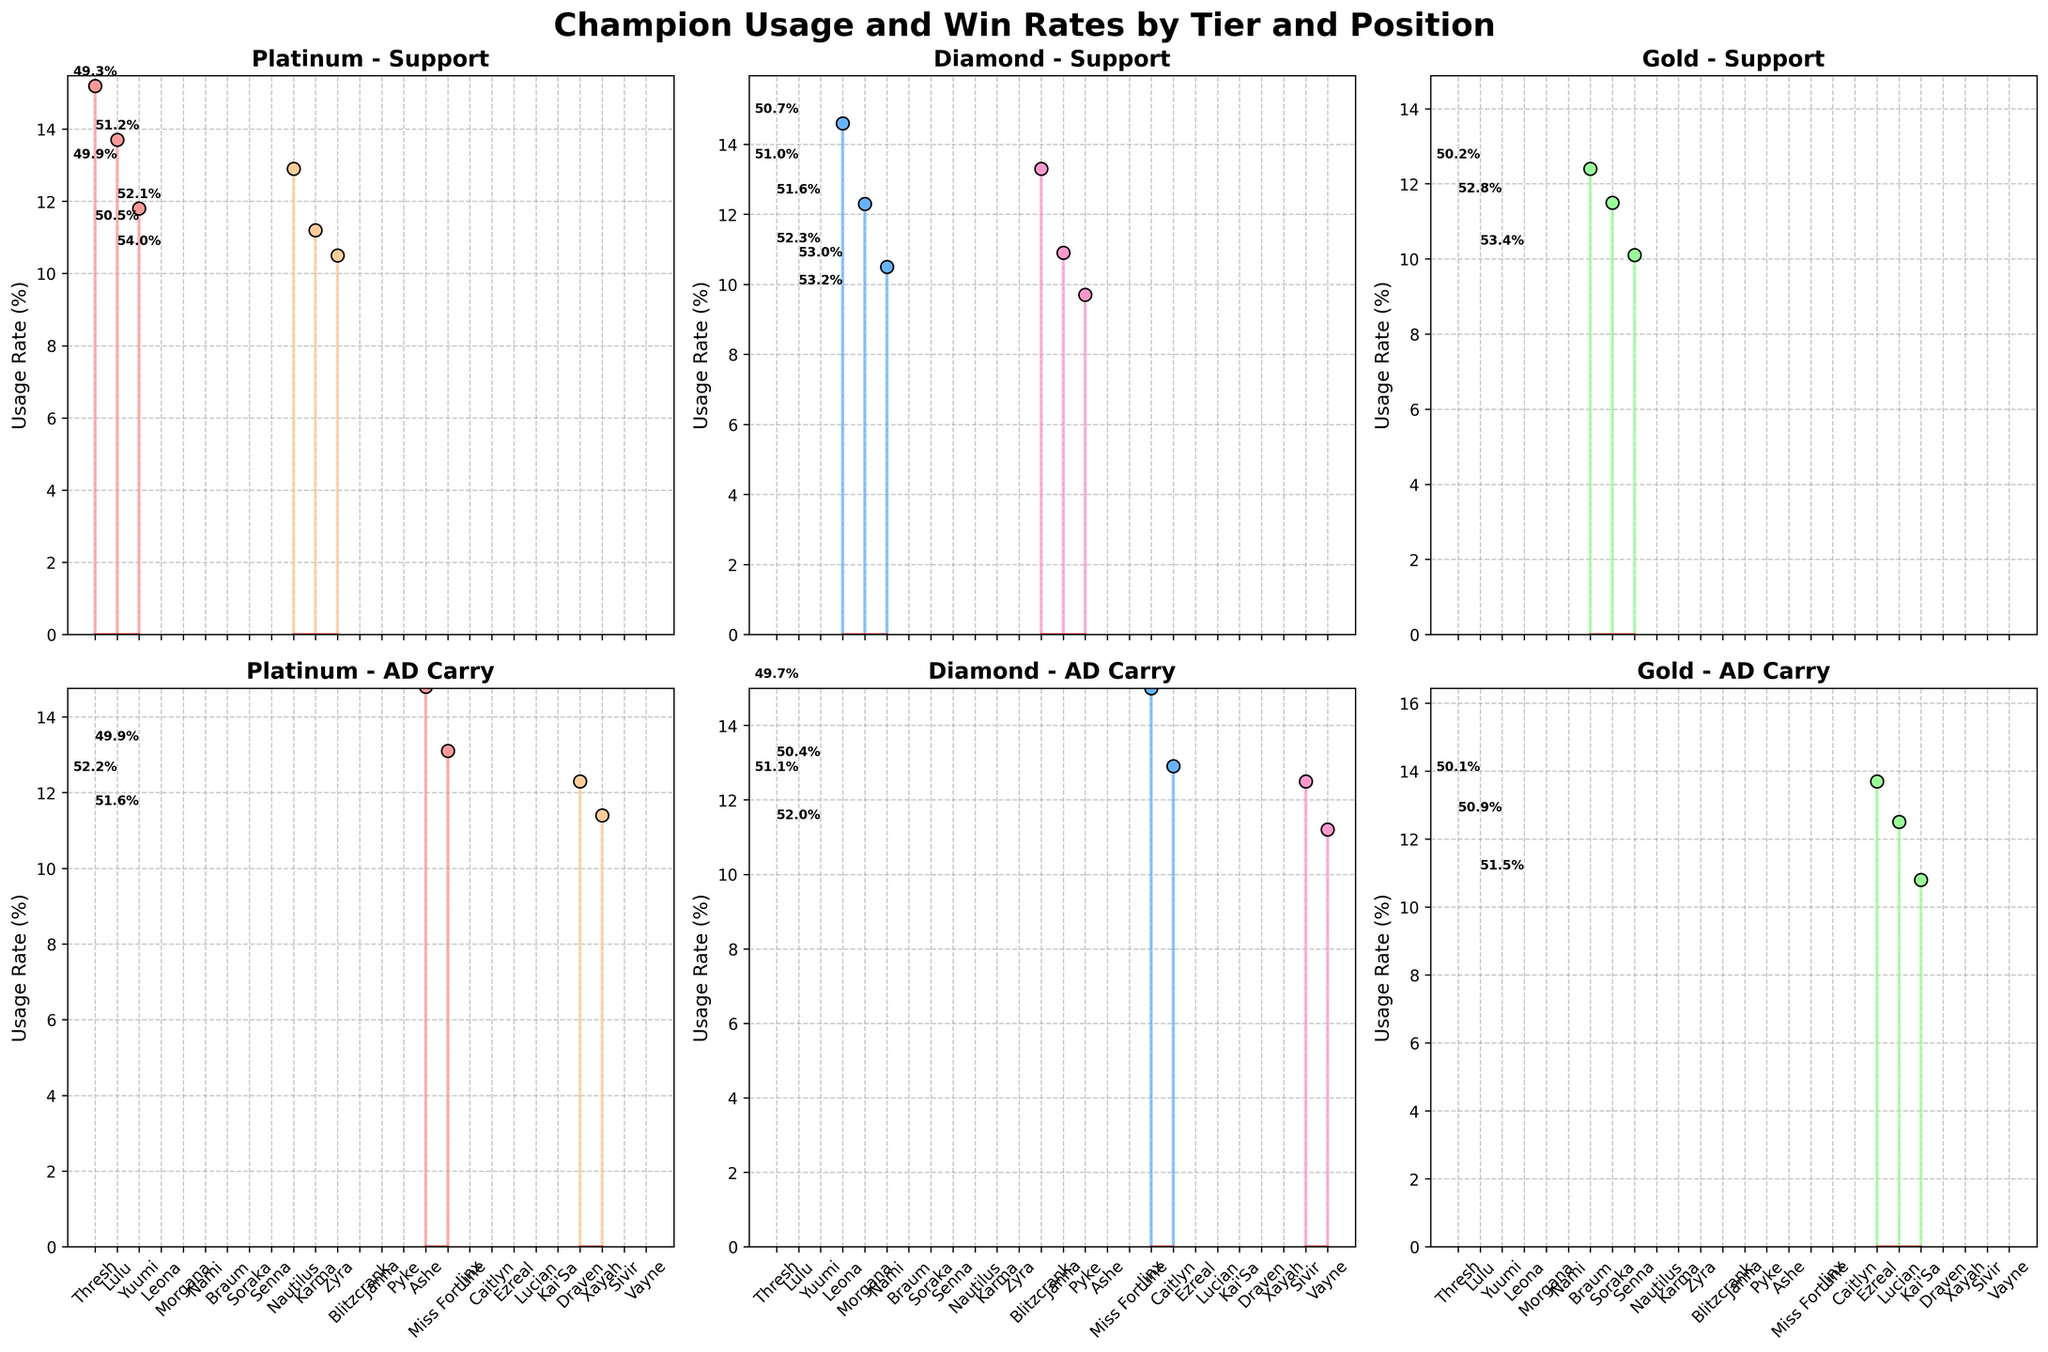What is the usage rate of Thresh in the Bronze tier as a Support? Look at the Bronze - Support subplot and find Thresh's stem line. Read the value on the y-axis where Thresh's stem line reaches.
Answer: 15.2% What is the title of the subplot in the top right? Each subplot is titled with the tier and position. The top right subplot corresponds to the third column in the top row.
Answer: Gold - Support Which champion has the highest win rate in the Silver tier for Support? Refer to the Silver - Support subplot and note the win rates annotated above each stem line. Identify the highest win rate.
Answer: Nami Compare the usage rates of Leona and Morgana in Silver tier as Support; who has a higher rate and by how much? In the Silver - Support subplot, find the usage rates of Leona (14.6%) and Morgana (12.3%). Subtract Morgana's rate from Leona's to find the difference.
Answer: Leona by 2.3% Which ADC champion has a higher win rate in the Gold tier, Ezreal or Kai'Sa? Look at the Gold - AD Carry subplot and compare the win rates annotated for Ezreal and Kai'Sa.
Answer: Kai'Sa What is the average win rate of support champions in the Diamond tier? In the Diamond - Support subplot, list all win rates (Blitzcrank 51.0%, Janna 52.3%, Pyke 53.2%). Add them and divide by the number of champions. (51.0 + 52.3 + 53.2) / 3
Answer: 52.2% Which tier and position combination has the support champion with the lowest usage rate? Compare the lowest usage rate among all subplots. Identify the tier and position that corresponds to the lowest value observed.
Answer: Diamond - Support What are the usage rates of champions in the Platinum tier as ADC? Look at the Platinum - AD Carry subplot and list the usage rates for each champion.
Answer: Draven 12.3%, Xayah 11.4% By how much does the win rate of Zyra in the Platinum tier exceed that of Nautilus in the same tier for support? In the Platinum - Support subplot, subtract Nautilus's win rate (49.9%) from Zyra's (54.0%).
Answer: 4.1% Does Jinx or Caitlyn have a higher win rate in the Silver tier as ADC? Check the Silver - AD Carry subplot and compare the win rates annotated for Jinx and Caitlyn.
Answer: Caitlyn 